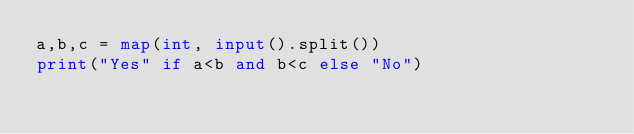<code> <loc_0><loc_0><loc_500><loc_500><_Python_>a,b,c = map(int, input().split())
print("Yes" if a<b and b<c else "No")
</code> 